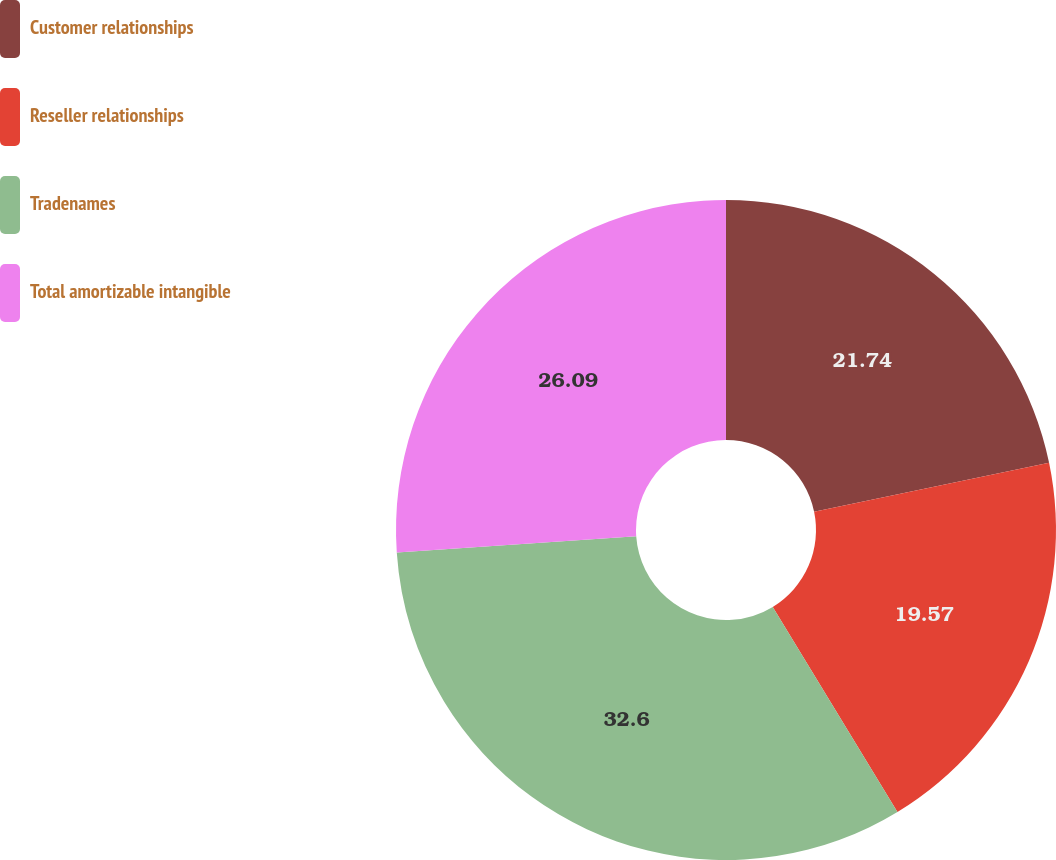<chart> <loc_0><loc_0><loc_500><loc_500><pie_chart><fcel>Customer relationships<fcel>Reseller relationships<fcel>Tradenames<fcel>Total amortizable intangible<nl><fcel>21.74%<fcel>19.57%<fcel>32.61%<fcel>26.09%<nl></chart> 